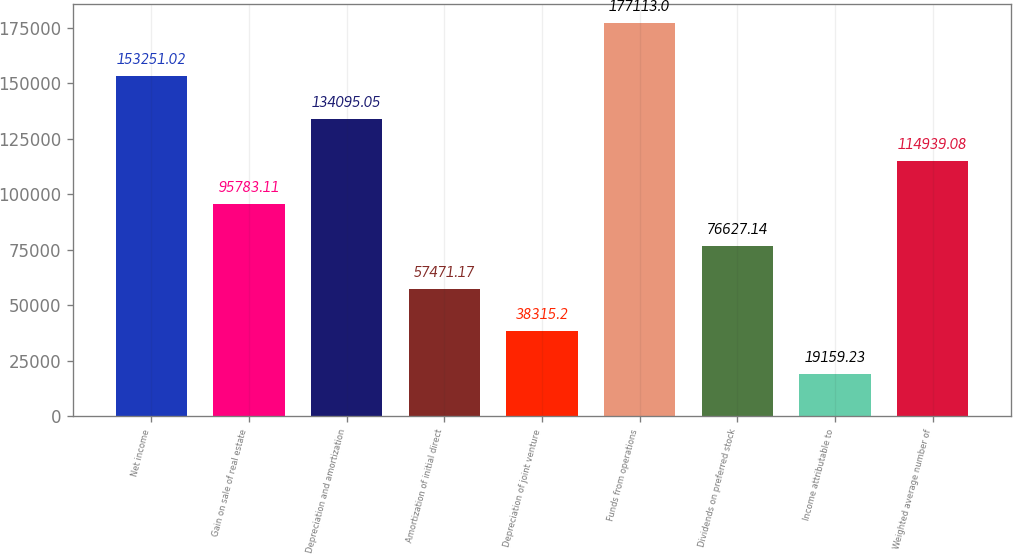Convert chart. <chart><loc_0><loc_0><loc_500><loc_500><bar_chart><fcel>Net income<fcel>Gain on sale of real estate<fcel>Depreciation and amortization<fcel>Amortization of initial direct<fcel>Depreciation of joint venture<fcel>Funds from operations<fcel>Dividends on preferred stock<fcel>Income attributable to<fcel>Weighted average number of<nl><fcel>153251<fcel>95783.1<fcel>134095<fcel>57471.2<fcel>38315.2<fcel>177113<fcel>76627.1<fcel>19159.2<fcel>114939<nl></chart> 